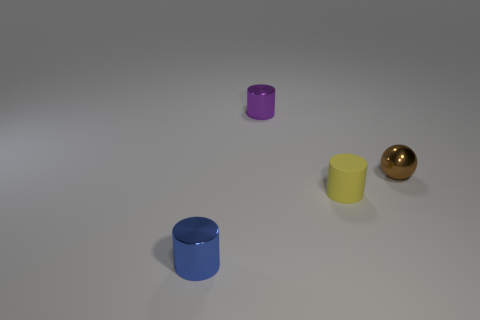Subtract all purple cylinders. How many cylinders are left? 2 Subtract all purple cylinders. How many cylinders are left? 2 Subtract all balls. How many objects are left? 3 Subtract 1 cylinders. How many cylinders are left? 2 Add 2 blue cylinders. How many blue cylinders exist? 3 Add 3 green cubes. How many objects exist? 7 Subtract 0 yellow balls. How many objects are left? 4 Subtract all brown cylinders. Subtract all purple blocks. How many cylinders are left? 3 Subtract all purple cylinders. How many cyan balls are left? 0 Subtract all metal cylinders. Subtract all tiny brown metal things. How many objects are left? 1 